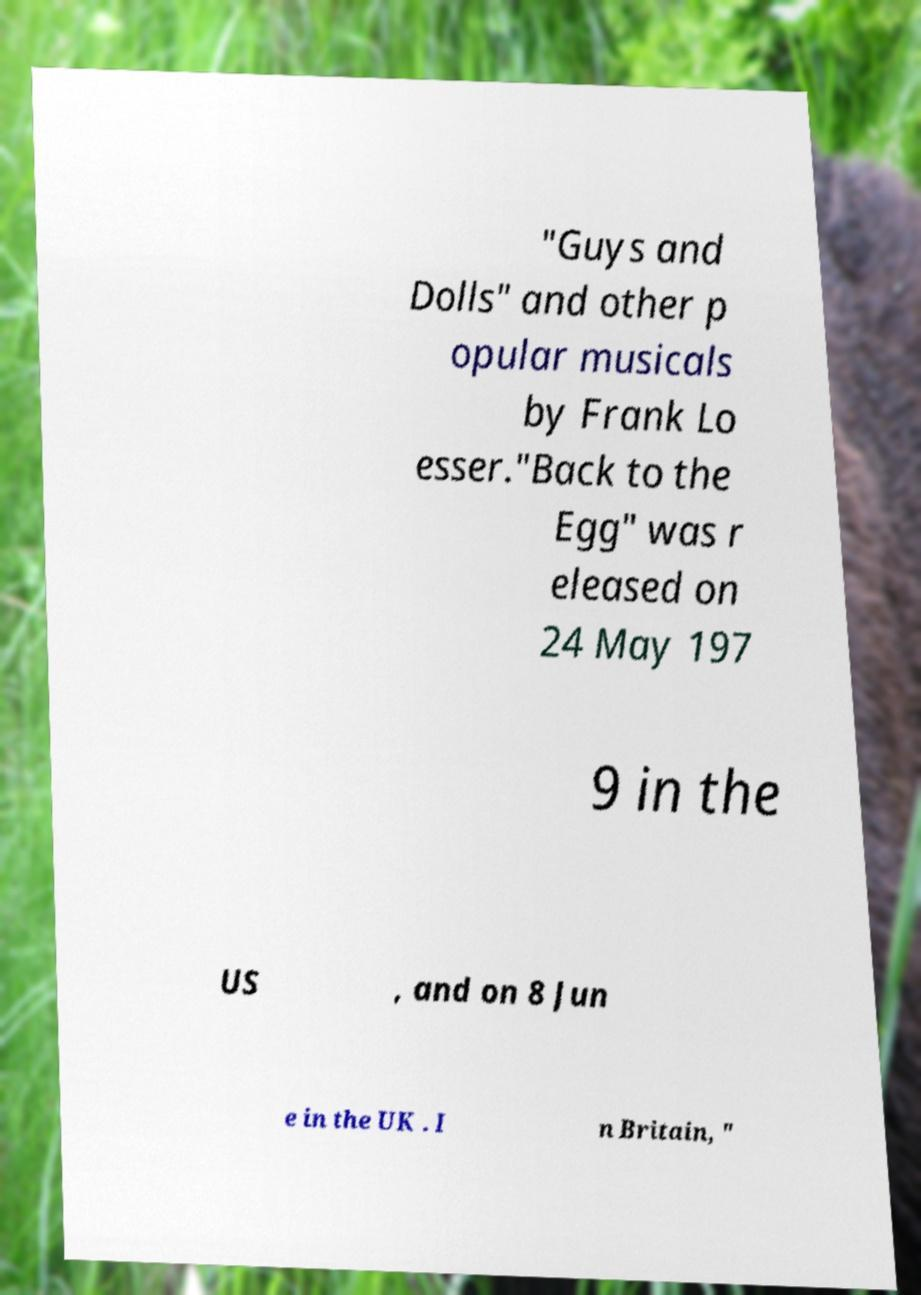Please read and relay the text visible in this image. What does it say? "Guys and Dolls" and other p opular musicals by Frank Lo esser."Back to the Egg" was r eleased on 24 May 197 9 in the US , and on 8 Jun e in the UK . I n Britain, " 